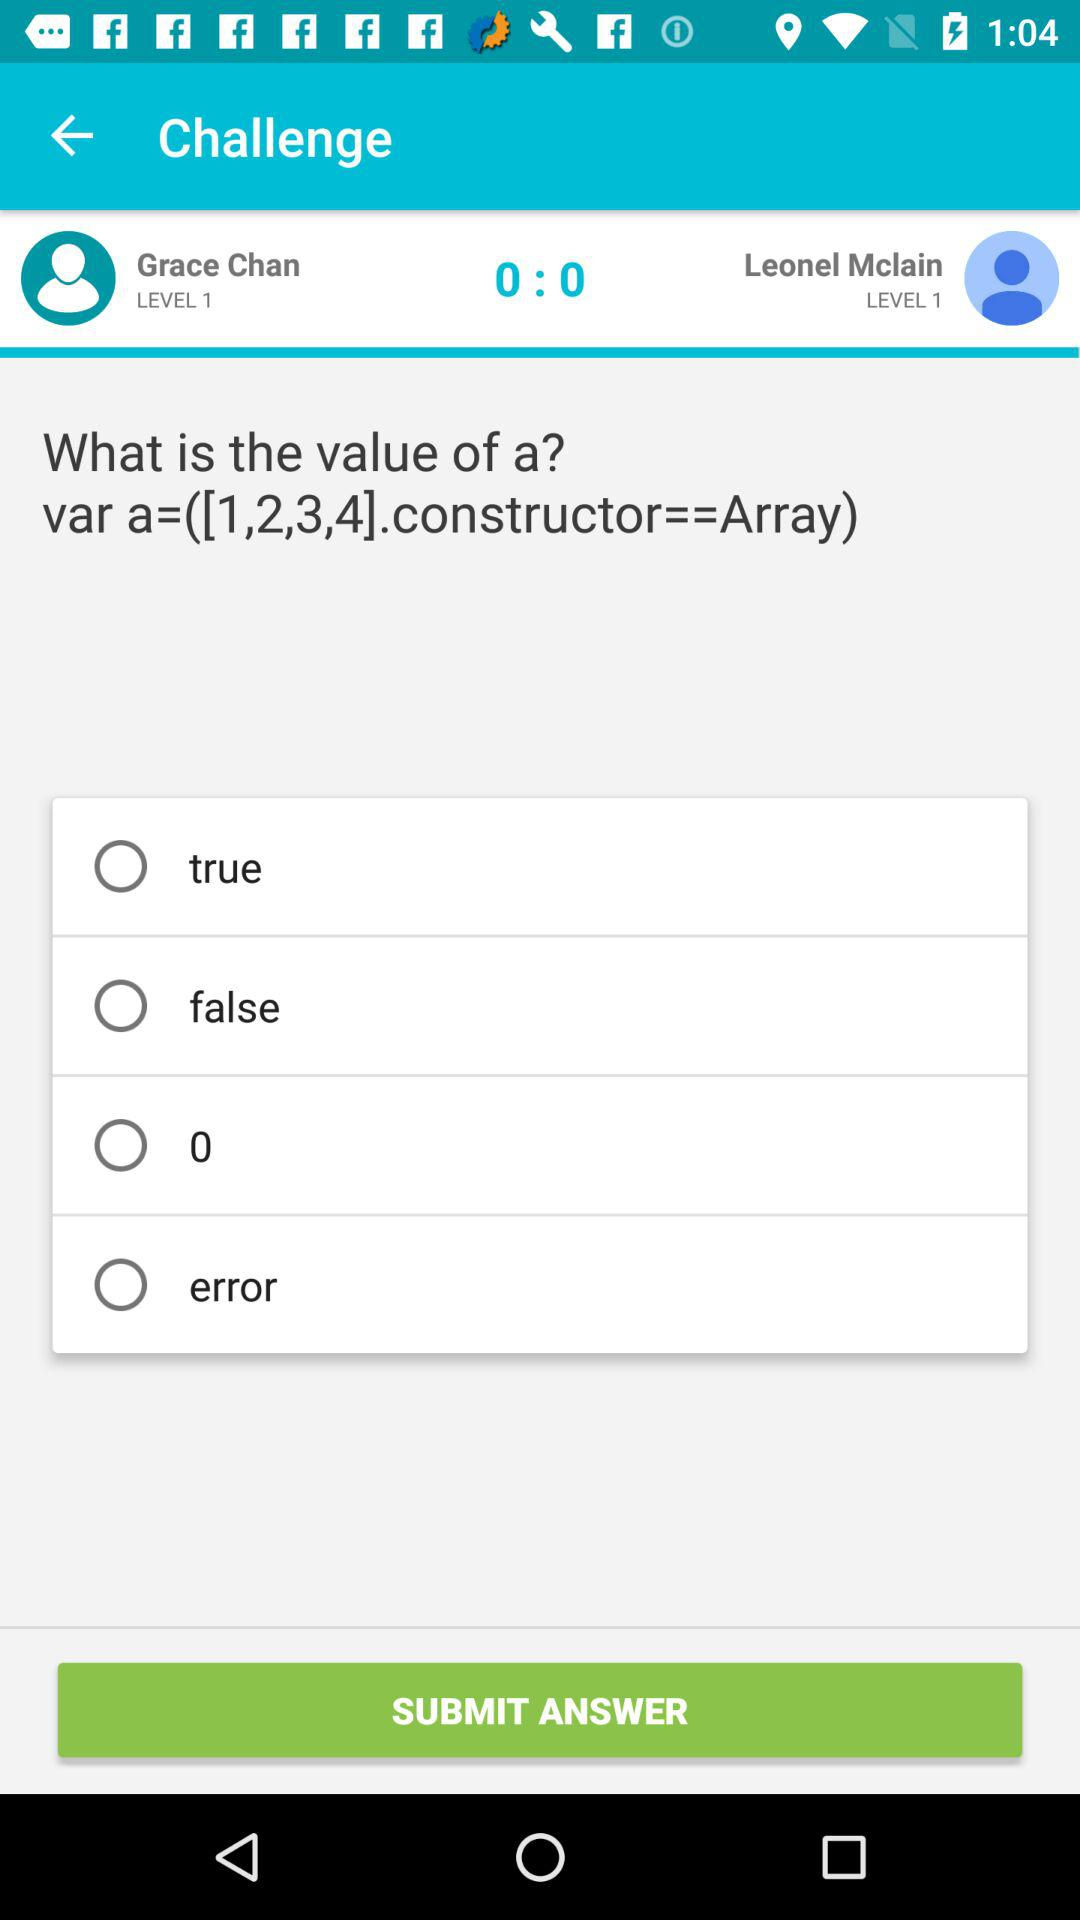What are the names of the challengers? The names of the challengers are : " Grace Chan" and "Leonel Mclain". 